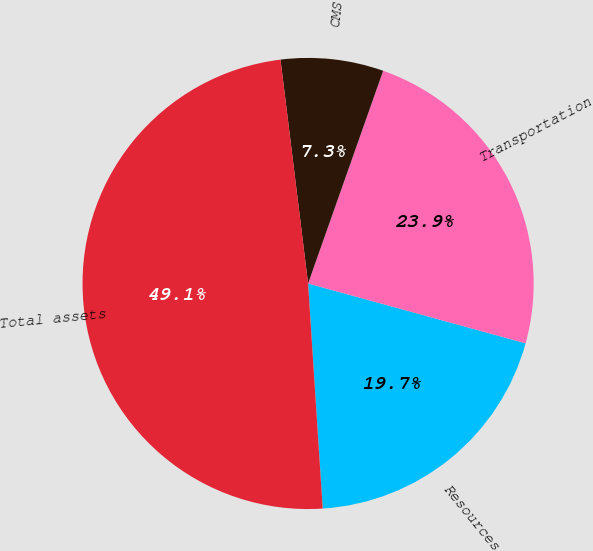Convert chart. <chart><loc_0><loc_0><loc_500><loc_500><pie_chart><fcel>Resources<fcel>Transportation<fcel>CMS<fcel>Total assets<nl><fcel>19.7%<fcel>23.87%<fcel>7.35%<fcel>49.08%<nl></chart> 